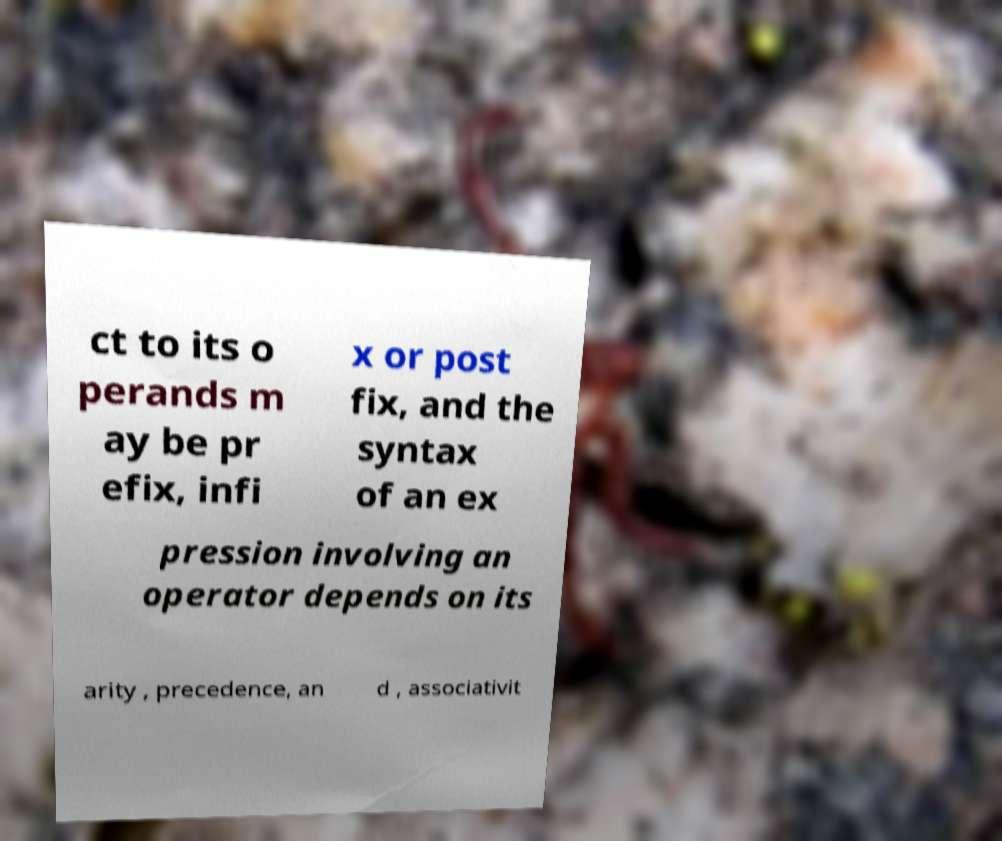There's text embedded in this image that I need extracted. Can you transcribe it verbatim? ct to its o perands m ay be pr efix, infi x or post fix, and the syntax of an ex pression involving an operator depends on its arity , precedence, an d , associativit 